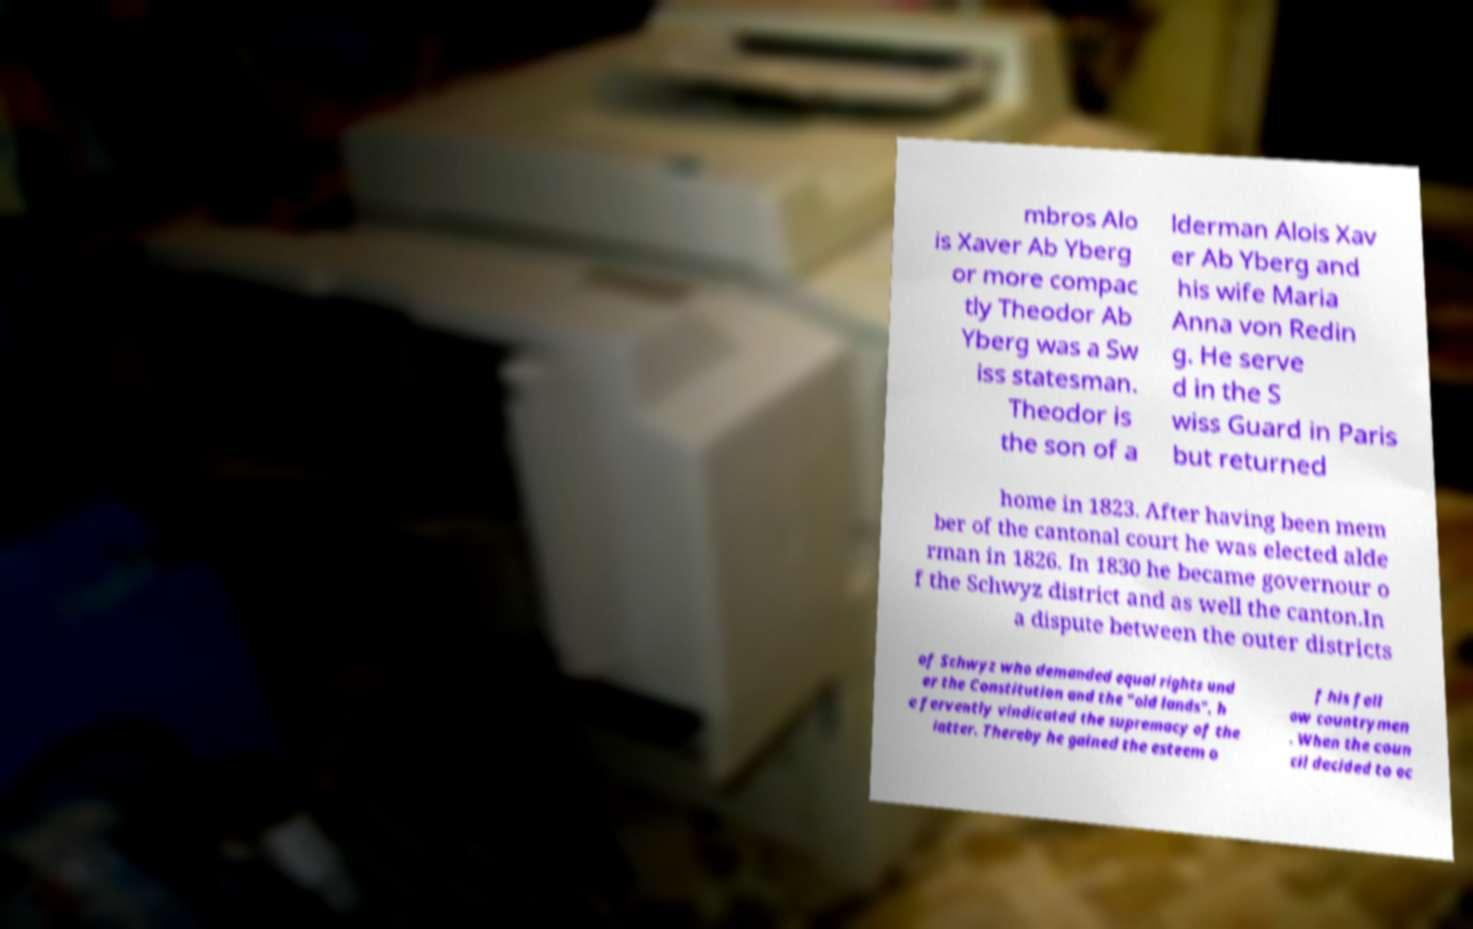Could you assist in decoding the text presented in this image and type it out clearly? mbros Alo is Xaver Ab Yberg or more compac tly Theodor Ab Yberg was a Sw iss statesman. Theodor is the son of a lderman Alois Xav er Ab Yberg and his wife Maria Anna von Redin g. He serve d in the S wiss Guard in Paris but returned home in 1823. After having been mem ber of the cantonal court he was elected alde rman in 1826. In 1830 he became governour o f the Schwyz district and as well the canton.In a dispute between the outer districts of Schwyz who demanded equal rights und er the Constitution and the "old lands", h e fervently vindicated the supremacy of the latter. Thereby he gained the esteem o f his fell ow countrymen . When the coun cil decided to oc 